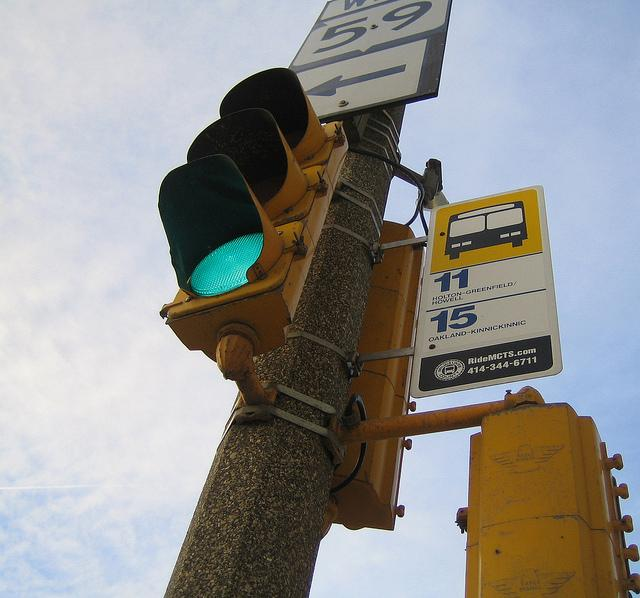What is the largest of the blue numbers on the sign? sign 